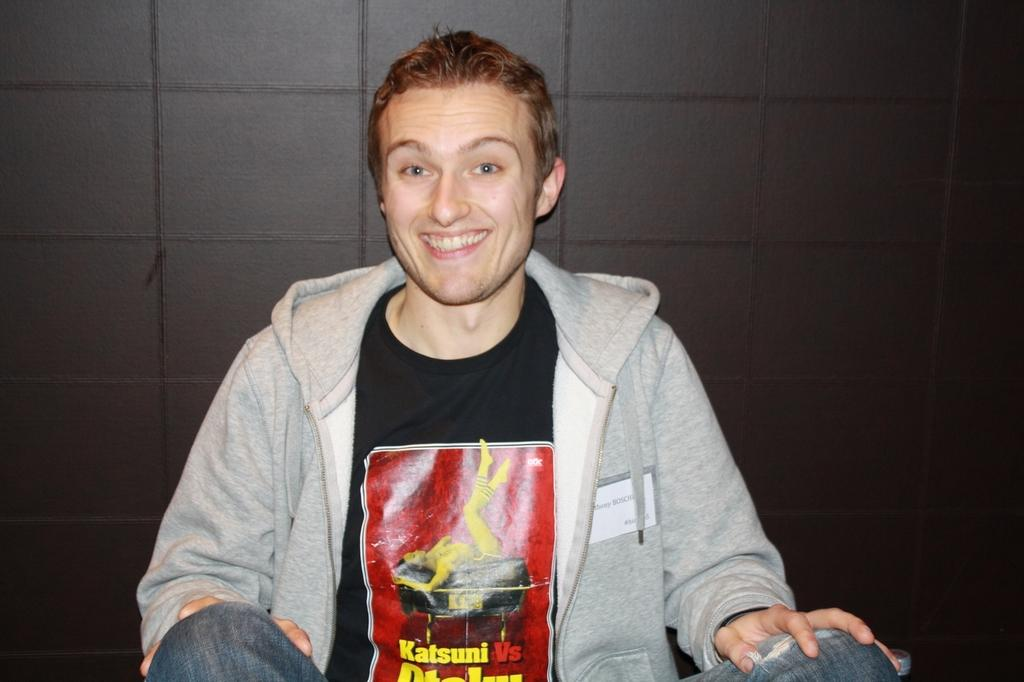Who is present in the image? There is a man in the image. What is the man doing in the image? The man is sitting. What is the man's facial expression in the image? The man is smiling. What can be seen on the man's t-shirt in the image? There is something written on the man's t-shirt. What is visible in the background of the image? There is a brown wall in the background of the image. What type of club does the man owe a debt to in the image? There is no mention of a club or debt in the image; it only shows a man sitting and smiling with something written on his t-shirt in front of a brown wall. 